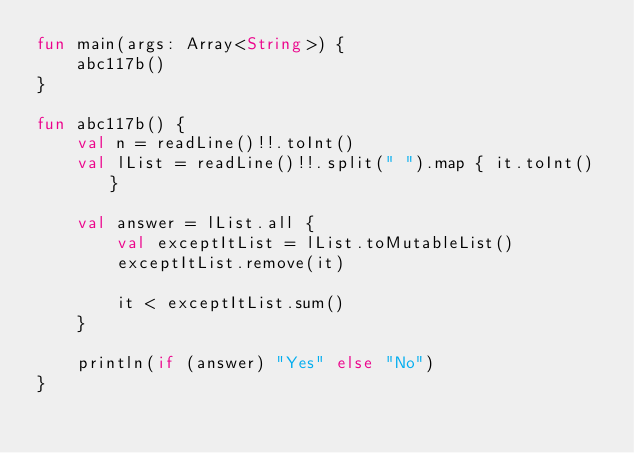<code> <loc_0><loc_0><loc_500><loc_500><_Kotlin_>fun main(args: Array<String>) {
    abc117b()
}

fun abc117b() {
    val n = readLine()!!.toInt()
    val lList = readLine()!!.split(" ").map { it.toInt() }

    val answer = lList.all {
        val exceptItList = lList.toMutableList()
        exceptItList.remove(it)

        it < exceptItList.sum()
    }

    println(if (answer) "Yes" else "No")
}
</code> 